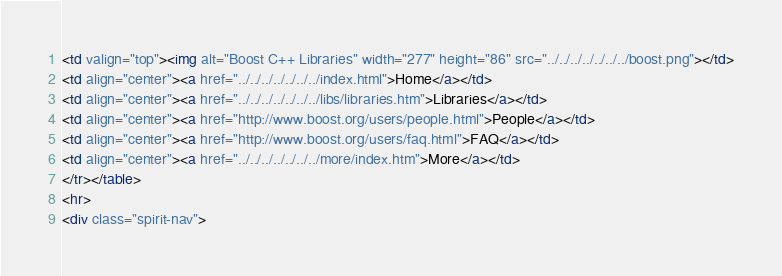Convert code to text. <code><loc_0><loc_0><loc_500><loc_500><_HTML_><td valign="top"><img alt="Boost C++ Libraries" width="277" height="86" src="../../../../../../../boost.png"></td>
<td align="center"><a href="../../../../../../../index.html">Home</a></td>
<td align="center"><a href="../../../../../../../libs/libraries.htm">Libraries</a></td>
<td align="center"><a href="http://www.boost.org/users/people.html">People</a></td>
<td align="center"><a href="http://www.boost.org/users/faq.html">FAQ</a></td>
<td align="center"><a href="../../../../../../../more/index.htm">More</a></td>
</tr></table>
<hr>
<div class="spirit-nav"></code> 